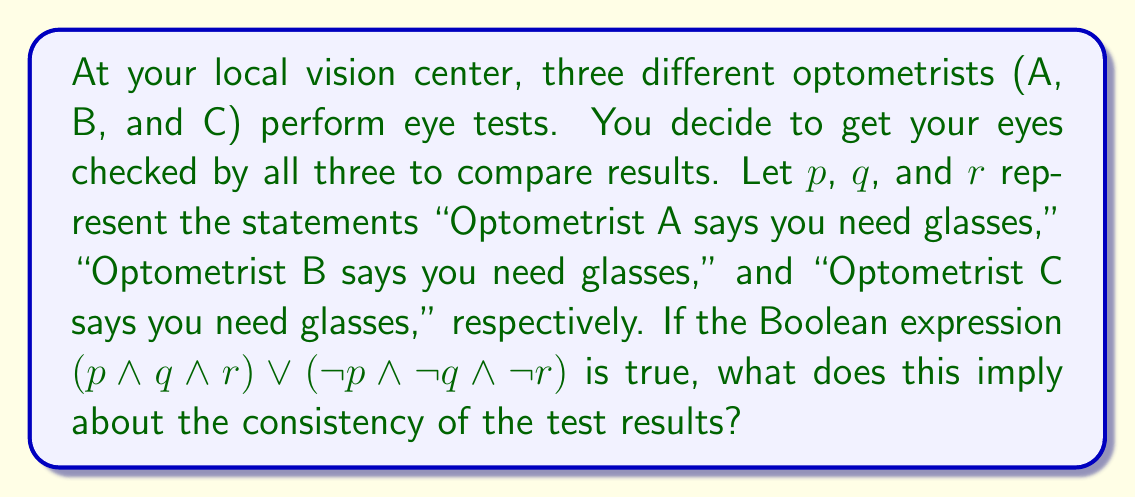Can you solve this math problem? Let's break this down step-by-step:

1) The given Boolean expression is $(p \wedge q \wedge r) \vee (\neg p \wedge \neg q \wedge \neg r)$

2) This expression is true in two cases:
   a) When $(p \wedge q \wedge r)$ is true, meaning all optometrists say you need glasses
   b) When $(\neg p \wedge \neg q \wedge \neg r)$ is true, meaning no optometrist says you need glasses

3) Let's consider the truth table for this expression:

   $$\begin{array}{|c|c|c|c|c|}
   \hline
   p & q & r & (p \wedge q \wedge r) & (\neg p \wedge \neg q \wedge \neg r) & \text{Result} \\
   \hline
   T & T & T & T & F & T \\
   T & T & F & F & F & F \\
   T & F & T & F & F & F \\
   T & F & F & F & F & F \\
   F & T & T & F & F & F \\
   F & T & F & F & F & F \\
   F & F & T & F & F & F \\
   F & F & F & F & T & T \\
   \hline
   \end{array}$$

4) The expression is true only when all optometrists agree (either all say you need glasses, or all say you don't).

5) This implies perfect consistency in the test results across all three optometrists.
Answer: Perfect consistency in test results 